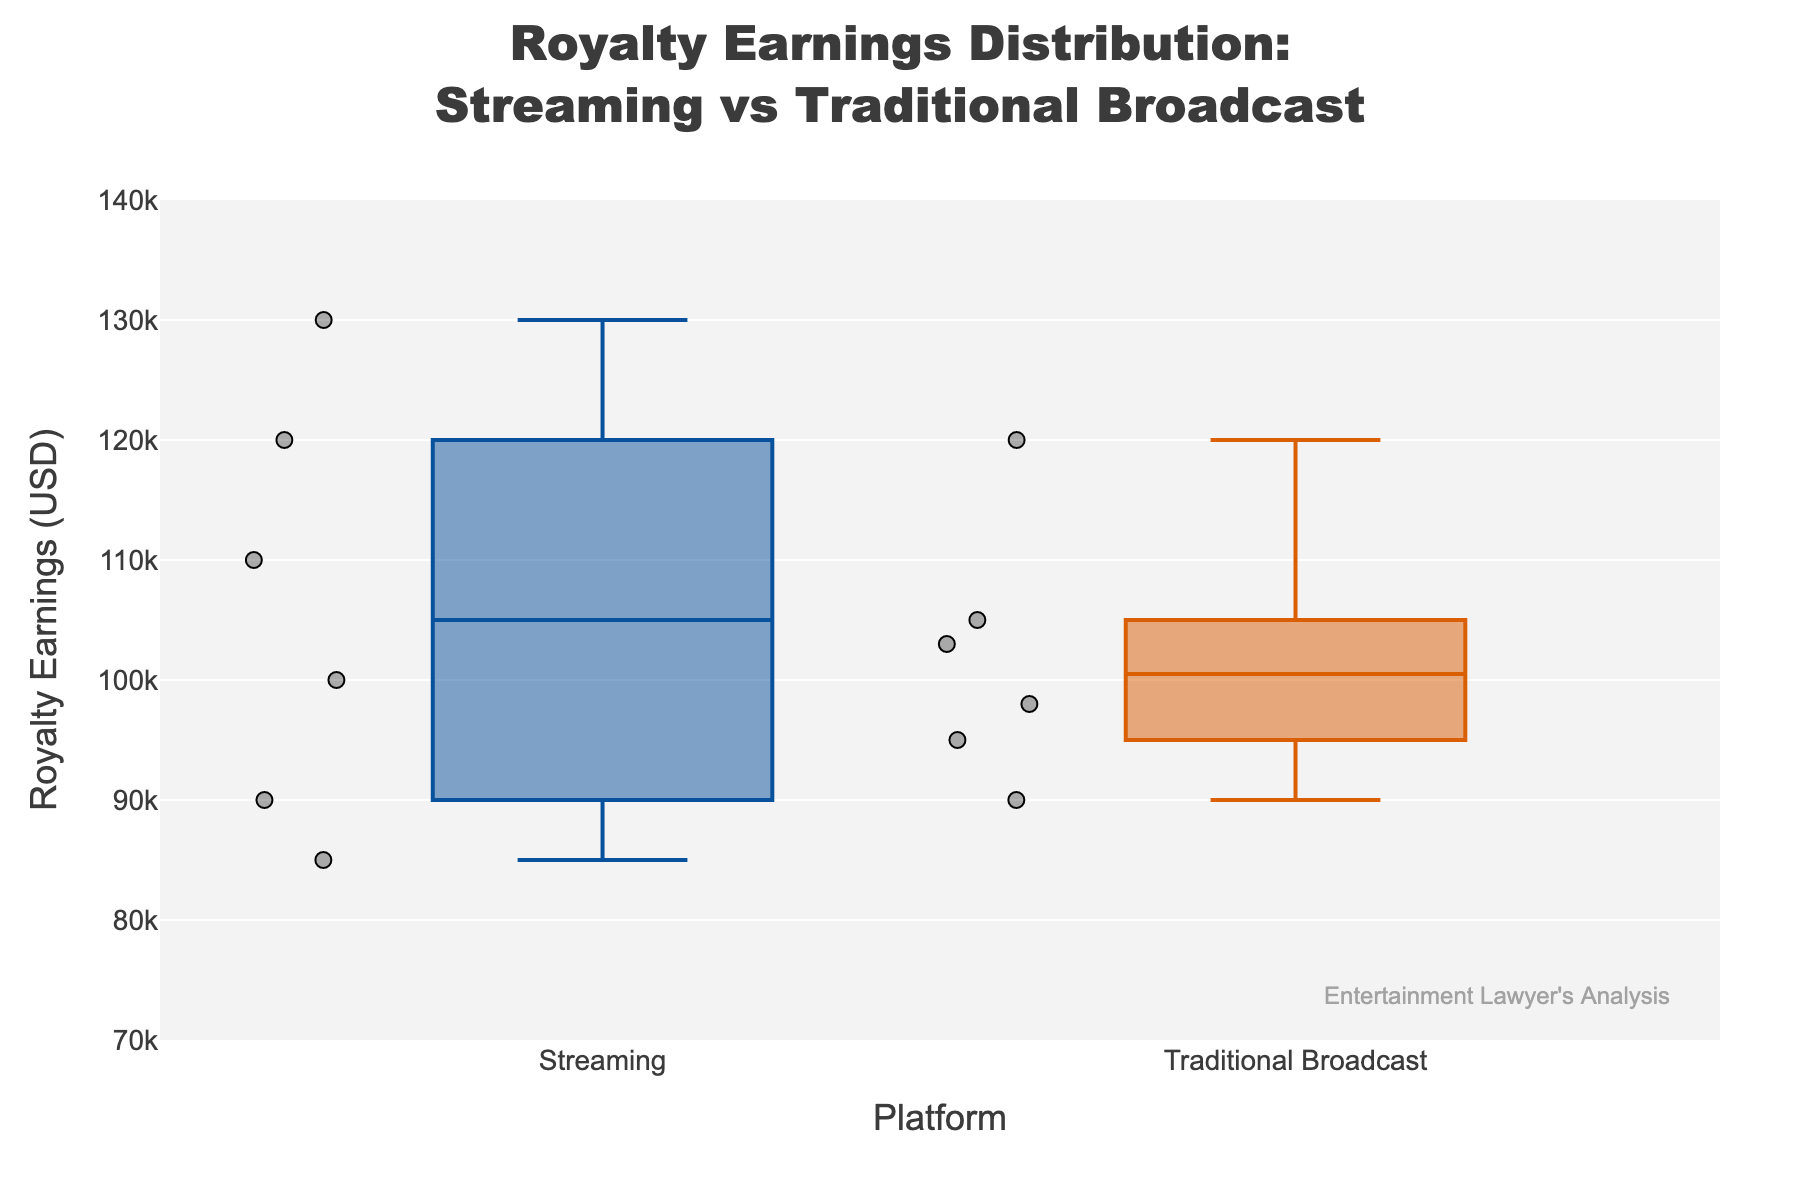what is the title of the figure? The title of the figure is located at the top of the plot, providing an overview of what the chart represents. It reads “Royalty Earnings Distribution: Streaming vs Traditional Broadcast.”
Answer: Royalty Earnings Distribution: Streaming vs Traditional Broadcast how many streaming platforms are shown in the figure? By counting the distinct box plots under the label "Streaming," you can determine there are six streaming platforms: Netflix, Hulu, Amazon Prime, Disney+, Apple TV+, and HBO Max.
Answer: 6 what is the range of the y-axis? The y-axis, labeled "Royalty Earnings (USD)," has ticks ranging from 70,000 to 140,000 USD. This can be observed from both the axis labels and the structured limits on the plot.
Answer: 70,000 to 140,000 USD which platform has the highest individual royalty earning? By examining the box plot points, the platform with the highest data point can be identified. In this case, Amazon Prime has the highest royalty earning at 130,000 USD.
Answer: Amazon Prime compare the median earnings of streaming platforms to traditional broadcast platforms. which has the higher median? The median is typically indicated by a line within each box. By comparing these lines, streaming platforms have a higher median, with Amazon Prime and Netflix visibly contributing higher medians compared to traditional broadcast platforms.
Answer: Streaming platforms which platform within traditional broadcast has the lowest royalty earnings? Observing individual data points within the traditional broadcast box plots, Showtime has the lowest earning at 90,000 USD.
Answer: Showtime calculate the interquartile range (IQR) for streaming platforms. The interquartile range (IQR) can be calculated by identifying the first quartile (Q1) and third quartile (Q3) values within the box plots for streaming platforms. From visual observation, Q1 is approximately 90,000 USD, and Q3 is approximately 120,000 USD. Thus, IQR = Q3 - Q1, which is 120,000 - 90,000 = 30,000 USD.
Answer: 30,000 USD determine the variability in royalty earnings between the two groups. which group shows greater variability? Variability can be assessed by the range and spread of the box plots. Traditional broadcast shows wider boxes and more dispersed points compared to the streaming group, indicating greater variability.
Answer: Traditional broadcast what is the purpose of the watermark at the bottom right of the figure? The watermark at the bottom right marked “Entertainment Lawyer's Analysis” is used to denote the source or the analyst responsible for the figure, giving attribution and authenticity.
Answer: Attribution is there any streaming platform that has lower earnings than any traditional broadcast platform? By directly comparing the individual data points within the box plots, Hulu and Apple TV+ from the streaming group have lower earnings (85,000 USD and 90,000 USD respectively) than CBS (105,000 USD) from the traditional broadcast group.
Answer: Yes 